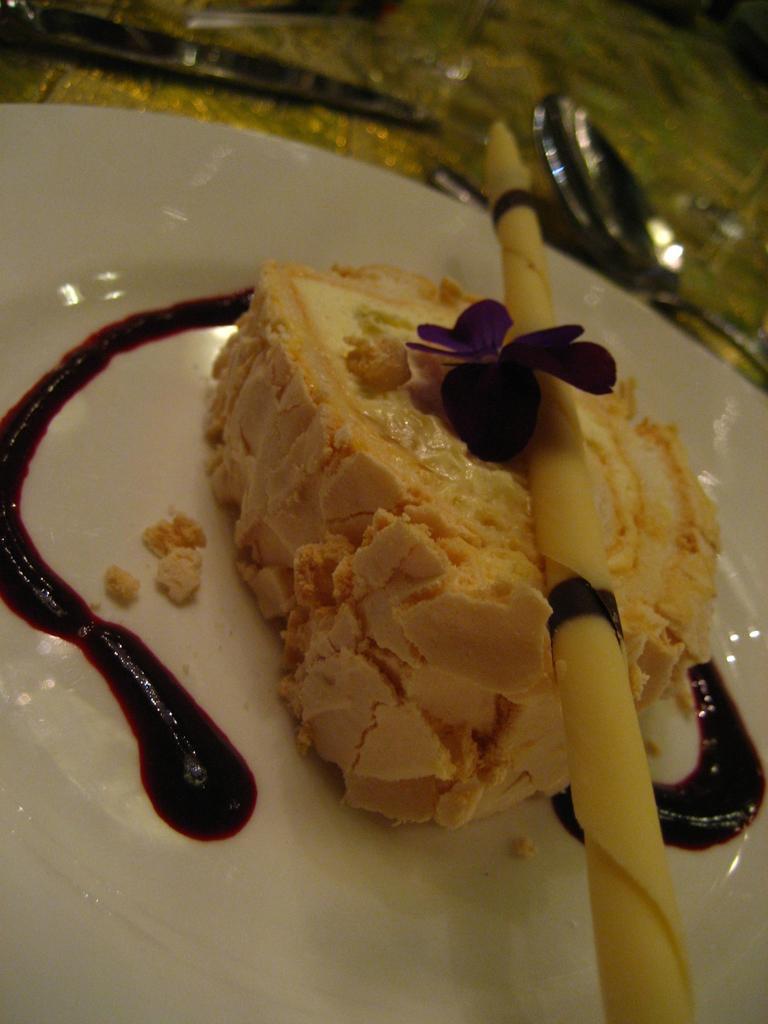Describe this image in one or two sentences. In this image there is a truncated plate on the surface, there is food on the plate, there is a flower on the food, there is a spoon truncated towards the right of the image, there is an object truncated towards the left of the image. 